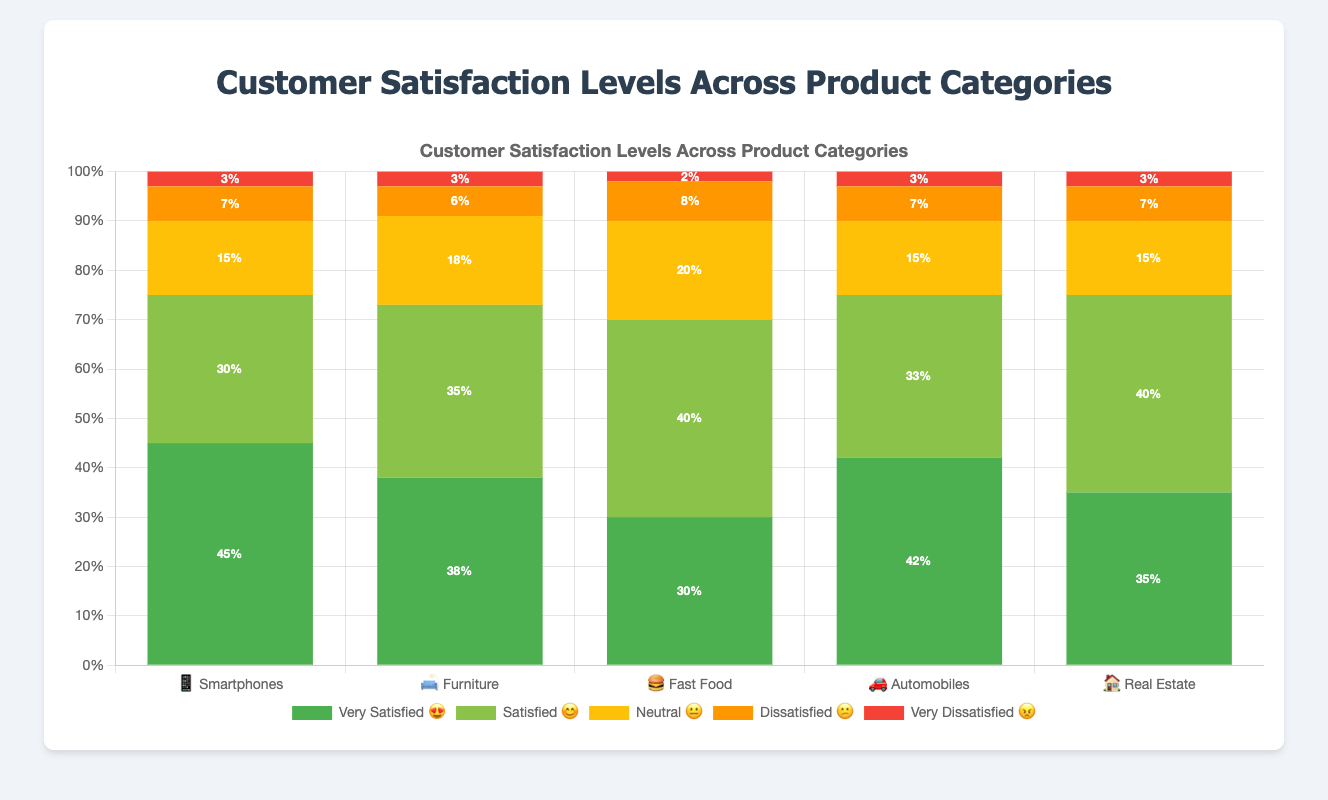Which product category has the highest percentage of 'Very Satisfied' customers? Looking at the 'Very Satisfied' 😍 bar, the 'Smartphones' 📱 category has the highest percentage at 45%.
Answer: Smartphones 📱 Which product category has the lowest percentage of 'Very Dissatisfied' customers? Checking the red bar for 'Very Dissatisfied' 😠, the 'Fast Food' 🍔 category has the lowest percentage at 2%.
Answer: Fast Food 🍔 What's the total percentage of satisfied customers (sum of 'Very Satisfied' and 'Satisfied') for Furniture? For Furniture 🛋️, 'Very Satisfied' is 38% and 'Satisfied' is 35%, so the total is 38% + 35% = 73%.
Answer: 73% Between Automobiles and Real Estate, which category has more 'Neutral' customers? The 'Neutral' 😐 bar shows 15% for both Automobiles 🚗 and Real Estate 🏠. As they are equal, neither has more.
Answer: Neither, both are 15% How many categories have less than 40% 'Very Satisfied' customers? Looking at the 'Very Satisfied' 😍 bars, the categories with less than 40% are Furniture 🛋️ and Fast Food 🍔, Real Estate 🏠. That's 3 categories.
Answer: 3 What's the difference in 'Satisfied' customer percentages between Fast Food and Real Estate? 'Satisfied' 😊 for Fast Food 🍔 is 40% and for Real Estate 🏠 is 40%. The difference is 40% - 40% = 0%.
Answer: 0% Which product category has the greatest variance in customer satisfaction levels? Smartphones 📱 range from 45% 'Very Satisfied' to 3% 'Very Dissatisfied'. This range of 42% suggests the greatest variance.
Answer: Smartphones 📱 What is the percentage of 'Dissatisfied' and 'Very Dissatisfied' customers combined for Automobiles? For Automobiles 🚗, 'Dissatisfied' is 7% and 'Very Dissatisfied' is 3%. Combined, it is 7% + 3% = 10%.
Answer: 10% 